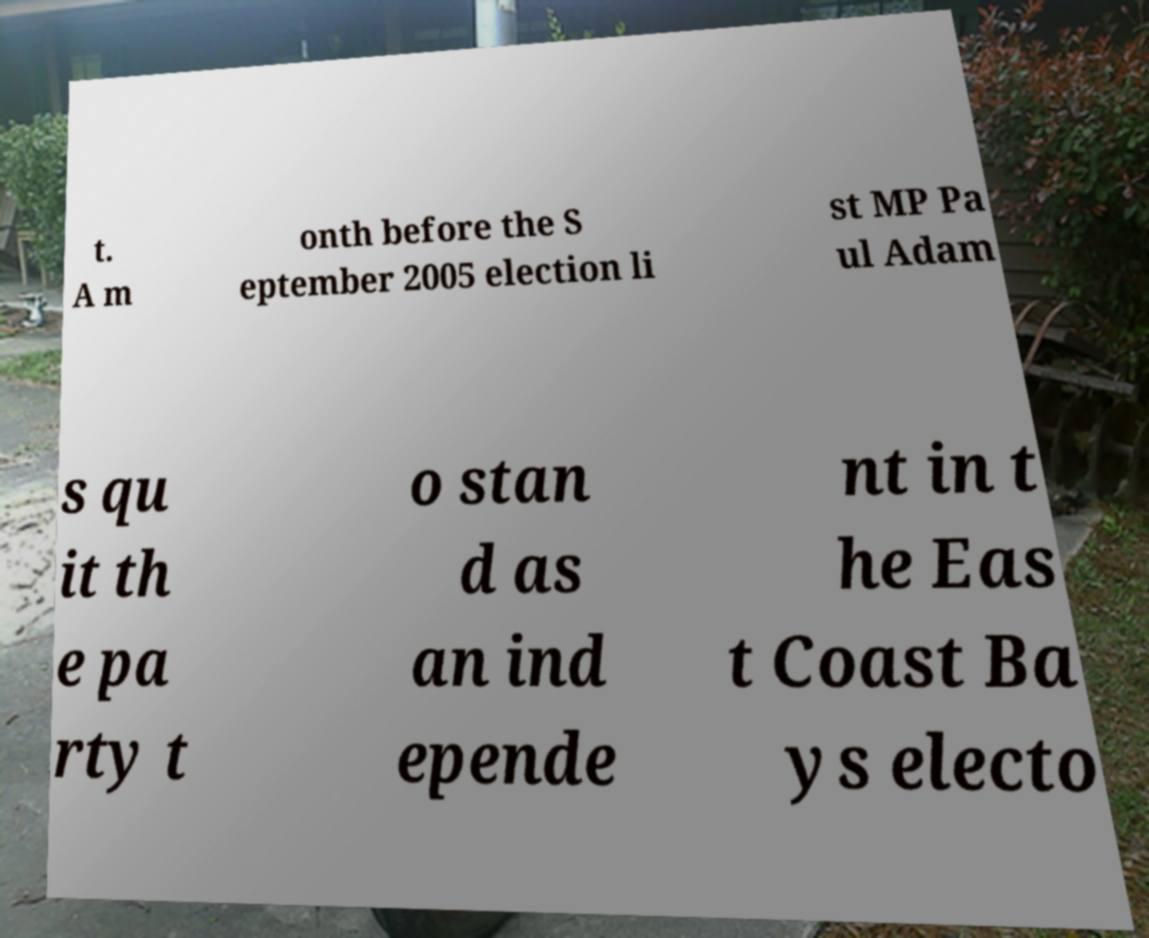Could you extract and type out the text from this image? t. A m onth before the S eptember 2005 election li st MP Pa ul Adam s qu it th e pa rty t o stan d as an ind epende nt in t he Eas t Coast Ba ys electo 